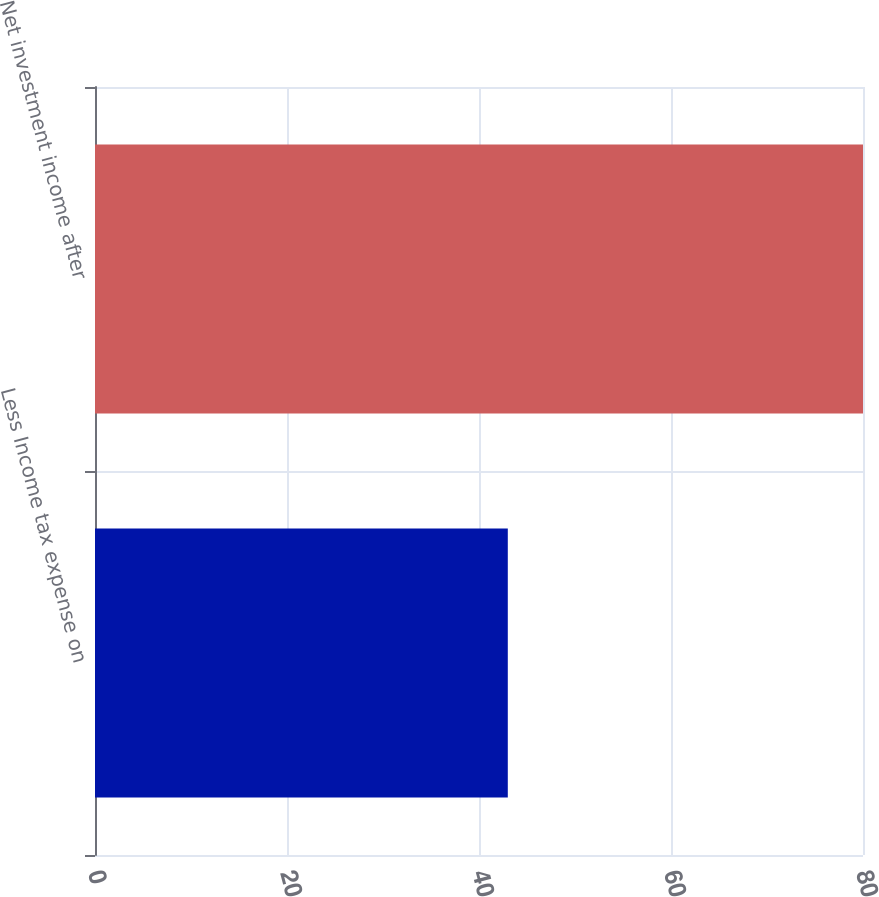Convert chart to OTSL. <chart><loc_0><loc_0><loc_500><loc_500><bar_chart><fcel>Less Income tax expense on<fcel>Net investment income after<nl><fcel>43<fcel>80<nl></chart> 